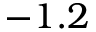<formula> <loc_0><loc_0><loc_500><loc_500>- 1 . 2</formula> 